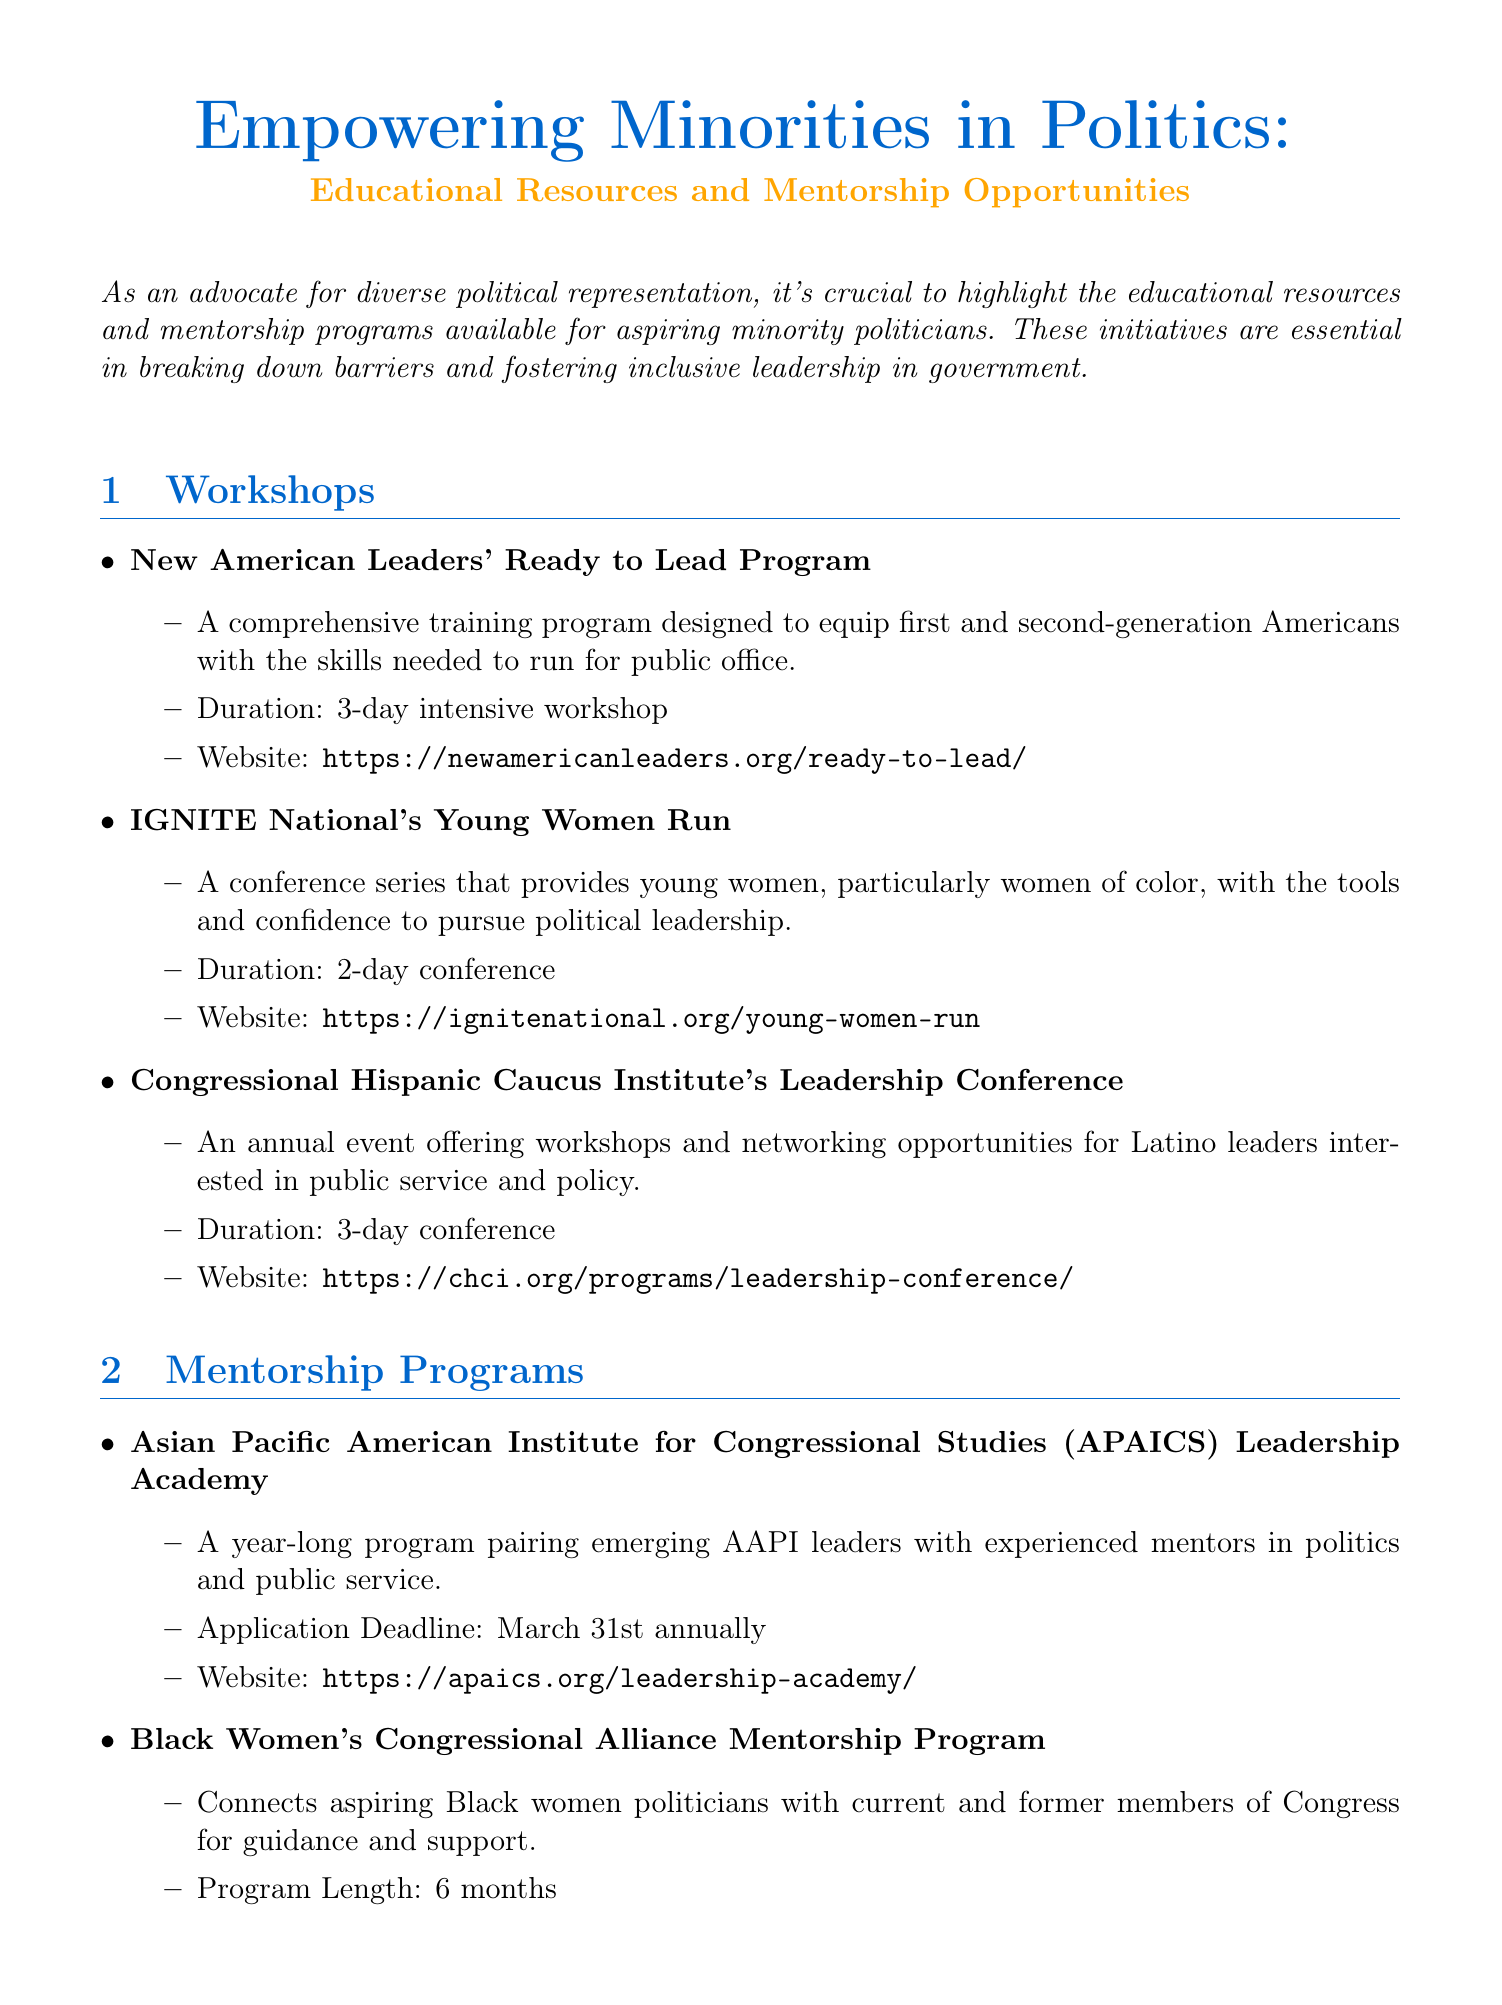What is the title of the newsletter? The title is mentioned at the beginning of the document, highlighting the focus on empowering minorities in politics.
Answer: Empowering Minorities in Politics: Educational Resources and Mentorship Opportunities How long is the New American Leaders' Ready to Lead Program? This program's length is explicitly stated in the workshop section of the document.
Answer: 3-day intensive workshop What is the application deadline for the APAICS Leadership Academy? The application deadline for this mentorship program is specified clearly in the document.
Answer: March 31st annually Which organization offers the Young Women Run conference? This question refers to one of the workshops provided in the document, which identifies the organizing body.
Answer: IGNITE National What type of resources does the Diversity in National Security Network provide? This refers to a specific section that outlines the types of resources available in the online resources section.
Answer: Curated resource library Which workshop focuses on Latino leaders? This asks for the specific workshop name related to Latino leadership, as indicated in the workshops list.
Answer: Congressional Hispanic Caucus Institute's Leadership Conference How long is the Black Women's Congressional Alliance Mentorship Program? It refers to a specific mentorship program's duration as stated in the document.
Answer: 6 months What is the format of She Should Run's Incubator program? This question targets the format for the online resource provided in the document, which is mentioned in the resources section.
Answer: Self-paced online courses 